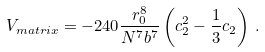<formula> <loc_0><loc_0><loc_500><loc_500>V _ { m a t r i x } = - 2 4 0 { \frac { r _ { 0 } ^ { 8 } } { N ^ { 7 } b ^ { 7 } } } \left ( c _ { 2 } ^ { 2 } - { \frac { 1 } { 3 } } c _ { 2 } \right ) \, .</formula> 